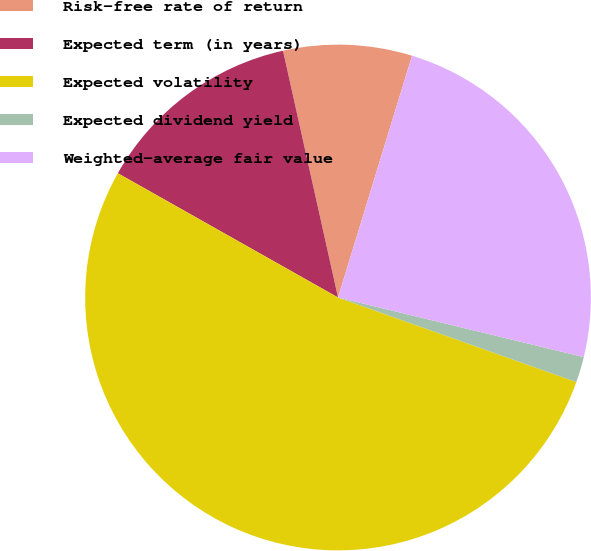Convert chart to OTSL. <chart><loc_0><loc_0><loc_500><loc_500><pie_chart><fcel>Risk-free rate of return<fcel>Expected term (in years)<fcel>Expected volatility<fcel>Expected dividend yield<fcel>Weighted-average fair value<nl><fcel>8.22%<fcel>13.33%<fcel>52.75%<fcel>1.64%<fcel>24.06%<nl></chart> 